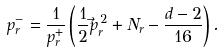Convert formula to latex. <formula><loc_0><loc_0><loc_500><loc_500>p _ { r } ^ { - } = \frac { 1 } { p _ { r } ^ { + } } \left ( \frac { 1 } { 2 } \vec { p } _ { r } ^ { \, 2 } + N _ { r } - \frac { d - 2 } { 1 6 } \right ) .</formula> 